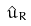Convert formula to latex. <formula><loc_0><loc_0><loc_500><loc_500>\hat { u } _ { R }</formula> 